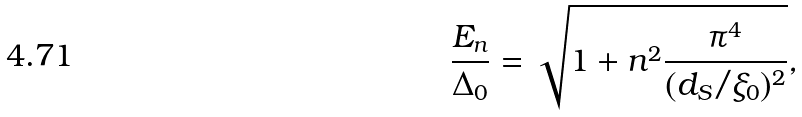<formula> <loc_0><loc_0><loc_500><loc_500>\frac { E _ { n } } { \Delta _ { 0 } } = \sqrt { 1 + n ^ { 2 } \frac { \pi ^ { 4 } } { ( d _ { S } / \xi _ { 0 } ) ^ { 2 } } } ,</formula> 